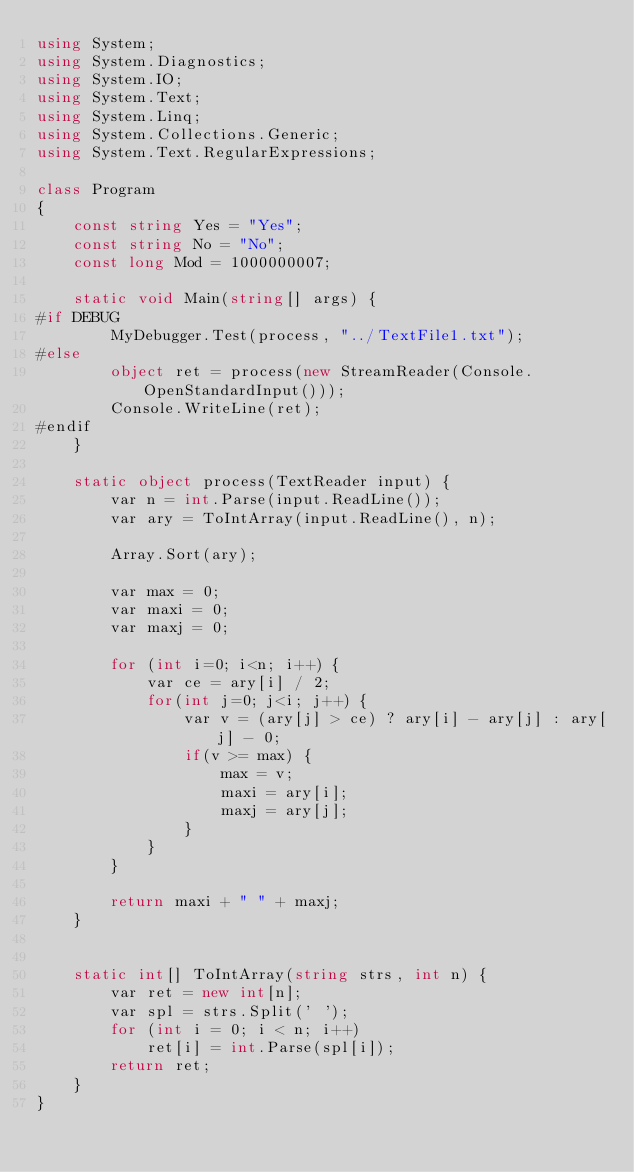<code> <loc_0><loc_0><loc_500><loc_500><_C#_>using System;
using System.Diagnostics;
using System.IO;
using System.Text;
using System.Linq;
using System.Collections.Generic;
using System.Text.RegularExpressions;

class Program
{
    const string Yes = "Yes";
    const string No = "No";
    const long Mod = 1000000007;

    static void Main(string[] args) {
#if DEBUG
        MyDebugger.Test(process, "../TextFile1.txt");
#else
        object ret = process(new StreamReader(Console.OpenStandardInput()));
        Console.WriteLine(ret);
#endif
    }

    static object process(TextReader input) {
        var n = int.Parse(input.ReadLine());
        var ary = ToIntArray(input.ReadLine(), n);

        Array.Sort(ary);

        var max = 0;
        var maxi = 0;
        var maxj = 0;

        for (int i=0; i<n; i++) {
            var ce = ary[i] / 2;
            for(int j=0; j<i; j++) {
                var v = (ary[j] > ce) ? ary[i] - ary[j] : ary[j] - 0;
                if(v >= max) {
                    max = v;
                    maxi = ary[i];
                    maxj = ary[j];
                }
            }
        }

        return maxi + " " + maxj;
    }


    static int[] ToIntArray(string strs, int n) {
        var ret = new int[n];
        var spl = strs.Split(' ');
        for (int i = 0; i < n; i++)
            ret[i] = int.Parse(spl[i]);
        return ret;
    }
}
</code> 